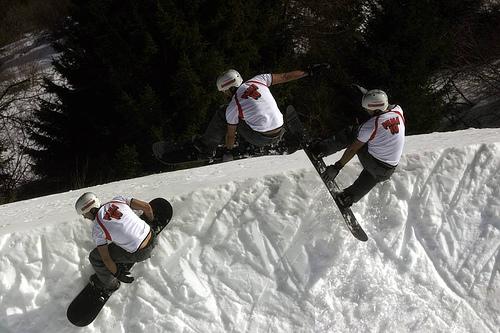Are people on water or snow?
Quick response, please. Snow. What color is the person's shirt?
Write a very short answer. White. What are the people doing?
Quick response, please. Snowboarding. 